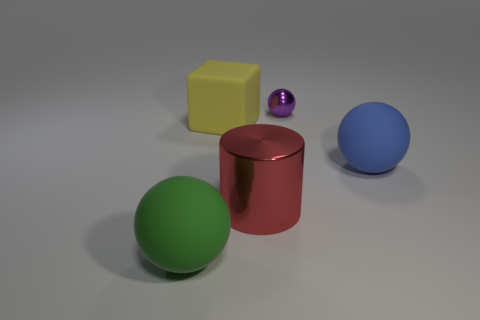Subtract all large matte spheres. How many spheres are left? 1 Subtract 1 balls. How many balls are left? 2 Subtract all red balls. Subtract all cyan cylinders. How many balls are left? 3 Add 5 large blue balls. How many objects exist? 10 Subtract all cubes. How many objects are left? 4 Subtract 0 green cylinders. How many objects are left? 5 Subtract all big blue rubber cubes. Subtract all spheres. How many objects are left? 2 Add 4 red metallic objects. How many red metallic objects are left? 5 Add 1 metal balls. How many metal balls exist? 2 